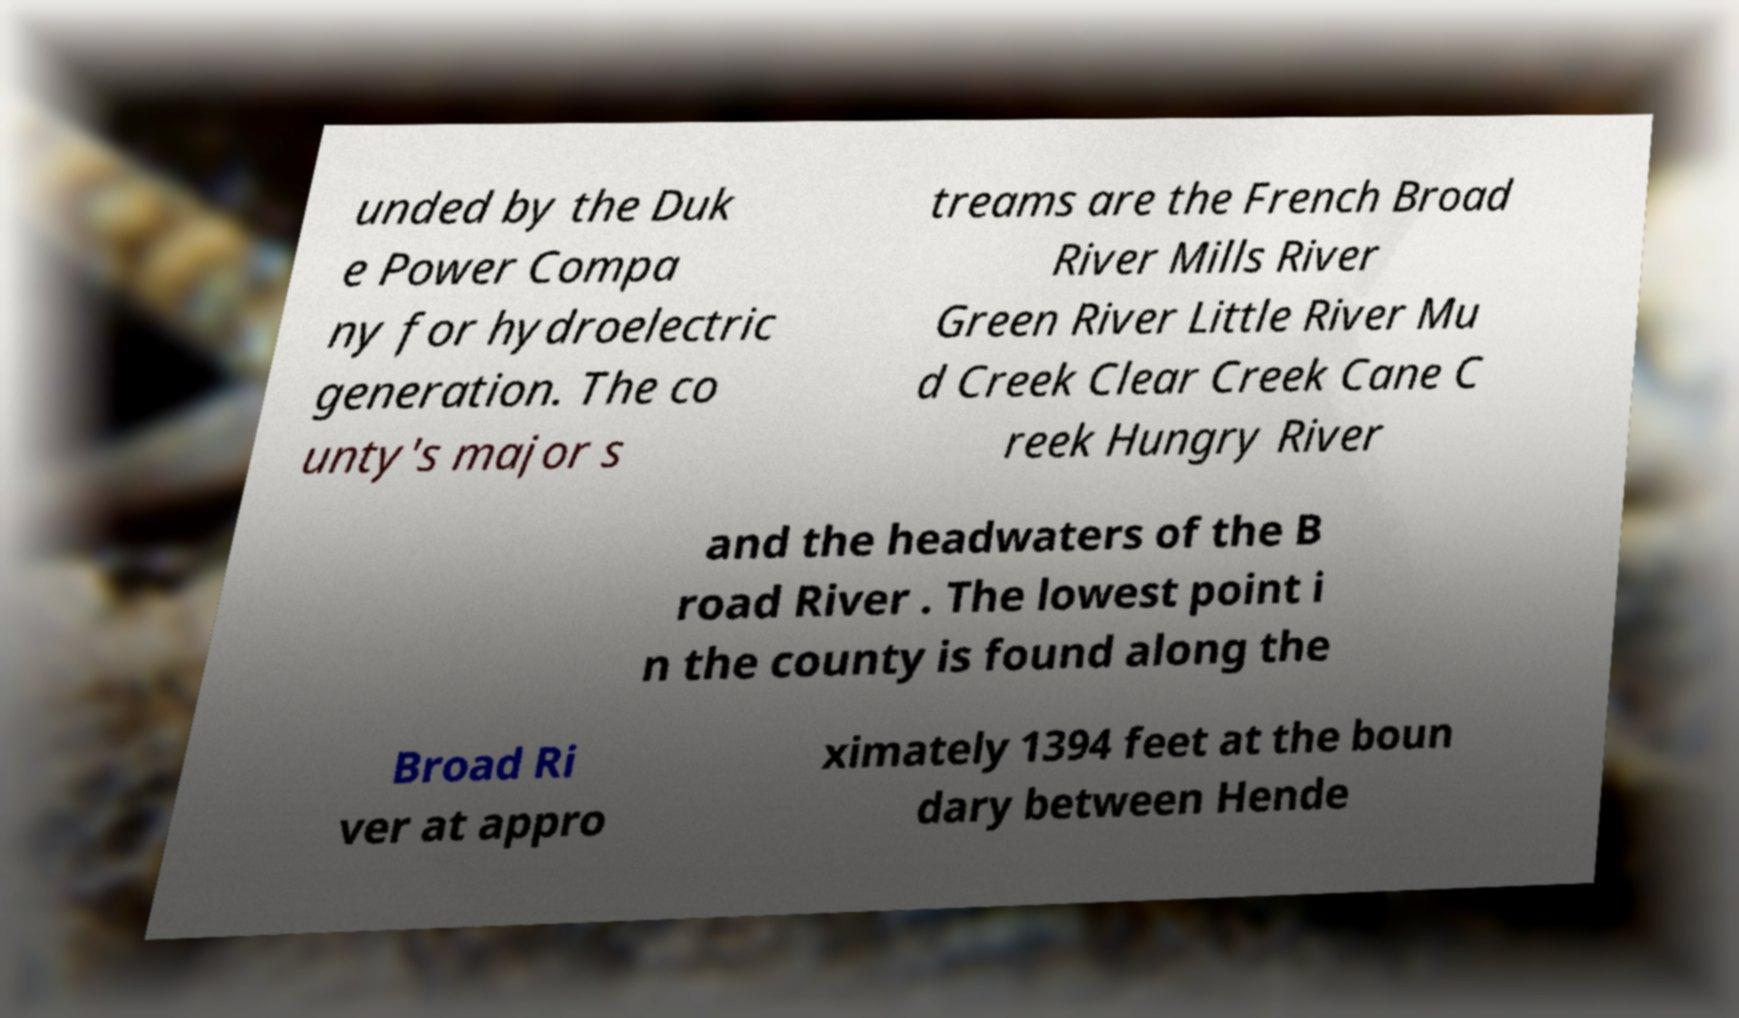Could you extract and type out the text from this image? unded by the Duk e Power Compa ny for hydroelectric generation. The co unty's major s treams are the French Broad River Mills River Green River Little River Mu d Creek Clear Creek Cane C reek Hungry River and the headwaters of the B road River . The lowest point i n the county is found along the Broad Ri ver at appro ximately 1394 feet at the boun dary between Hende 